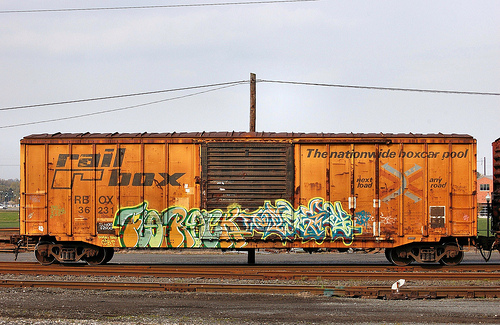<image>
Is the train above the track? No. The train is not positioned above the track. The vertical arrangement shows a different relationship. 